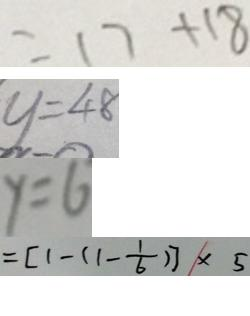<formula> <loc_0><loc_0><loc_500><loc_500>= 1 7 + 1 8 
 y = 4 8 
 y = 6 
 = [ 1 - ( 1 - \frac { 1 } { 6 } ) ] \times 5</formula> 